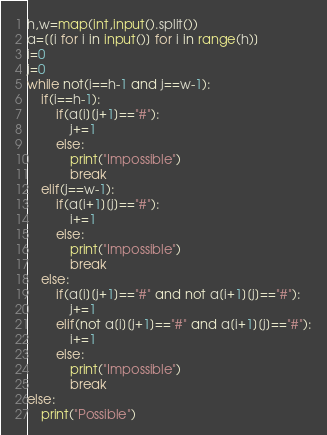Convert code to text. <code><loc_0><loc_0><loc_500><loc_500><_Python_>h,w=map(int,input().split())
a=[[i for i in input()] for i in range(h)]
i=0
j=0
while not(i==h-1 and j==w-1):
    if(i==h-1):
        if(a[i][j+1]=="#"):
            j+=1
        else:
            print("Impossible")
            break
    elif(j==w-1):
        if(a[i+1][j]=="#"):
            i+=1
        else:
            print("Impossible")
            break
    else:
        if(a[i][j+1]=="#" and not a[i+1][j]=="#"):
            j+=1
        elif(not a[i][j+1]=="#" and a[i+1][j]=="#"):
            i+=1
        else:
            print("Impossible")
            break
else:
    print("Possible")</code> 